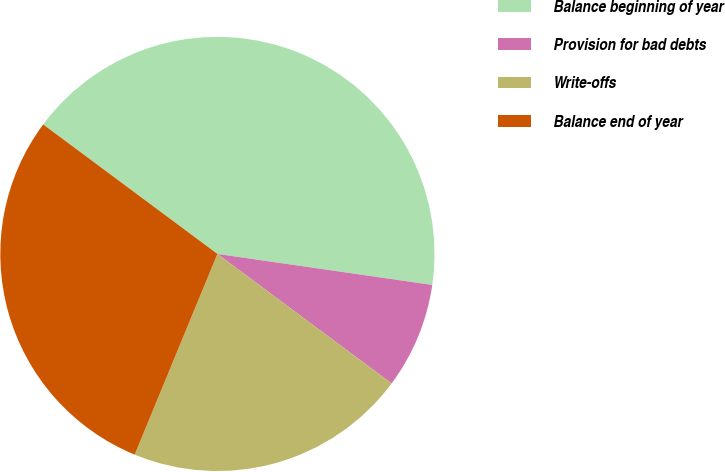<chart> <loc_0><loc_0><loc_500><loc_500><pie_chart><fcel>Balance beginning of year<fcel>Provision for bad debts<fcel>Write-offs<fcel>Balance end of year<nl><fcel>42.11%<fcel>7.89%<fcel>21.05%<fcel>28.95%<nl></chart> 